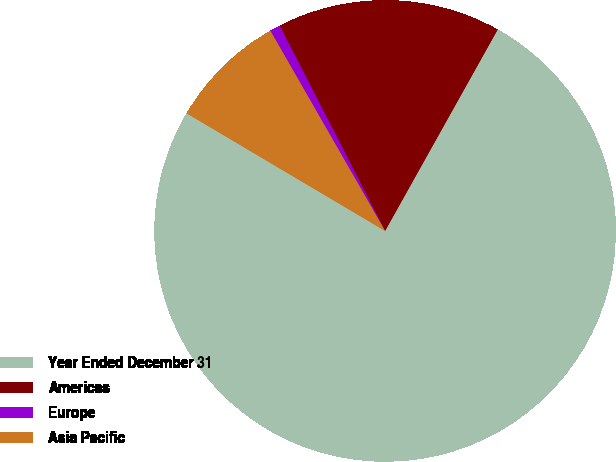<chart> <loc_0><loc_0><loc_500><loc_500><pie_chart><fcel>Year Ended December 31<fcel>Americas<fcel>Europe<fcel>Asia Pacific<nl><fcel>75.4%<fcel>15.67%<fcel>0.73%<fcel>8.2%<nl></chart> 